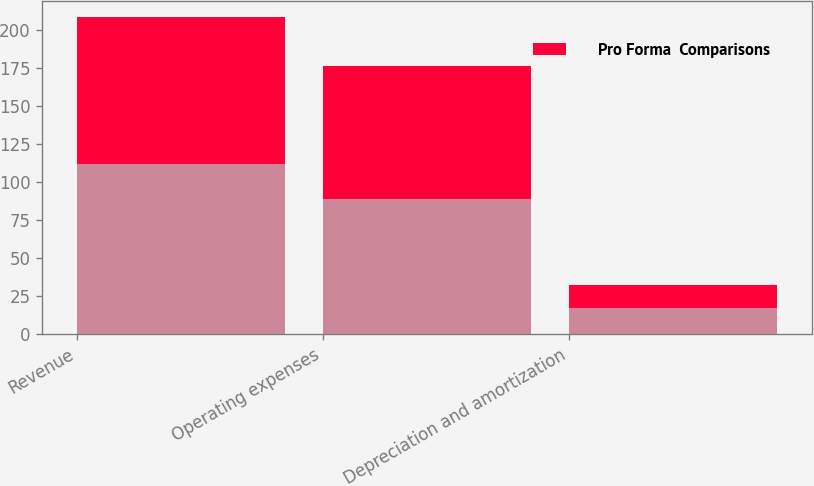<chart> <loc_0><loc_0><loc_500><loc_500><stacked_bar_chart><ecel><fcel>Revenue<fcel>Operating expenses<fcel>Depreciation and amortization<nl><fcel>nan<fcel>111.9<fcel>88.7<fcel>17.2<nl><fcel>Pro Forma  Comparisons<fcel>96.6<fcel>87.5<fcel>15<nl></chart> 